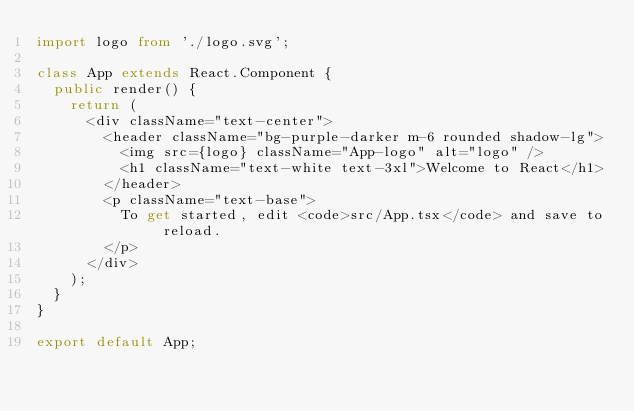Convert code to text. <code><loc_0><loc_0><loc_500><loc_500><_TypeScript_>import logo from './logo.svg';

class App extends React.Component {
  public render() {
    return (
      <div className="text-center">
        <header className="bg-purple-darker m-6 rounded shadow-lg">
          <img src={logo} className="App-logo" alt="logo" />
          <h1 className="text-white text-3xl">Welcome to React</h1>
        </header>
        <p className="text-base">
          To get started, edit <code>src/App.tsx</code> and save to reload.
        </p>
      </div>
    );
  }
}

export default App;
</code> 